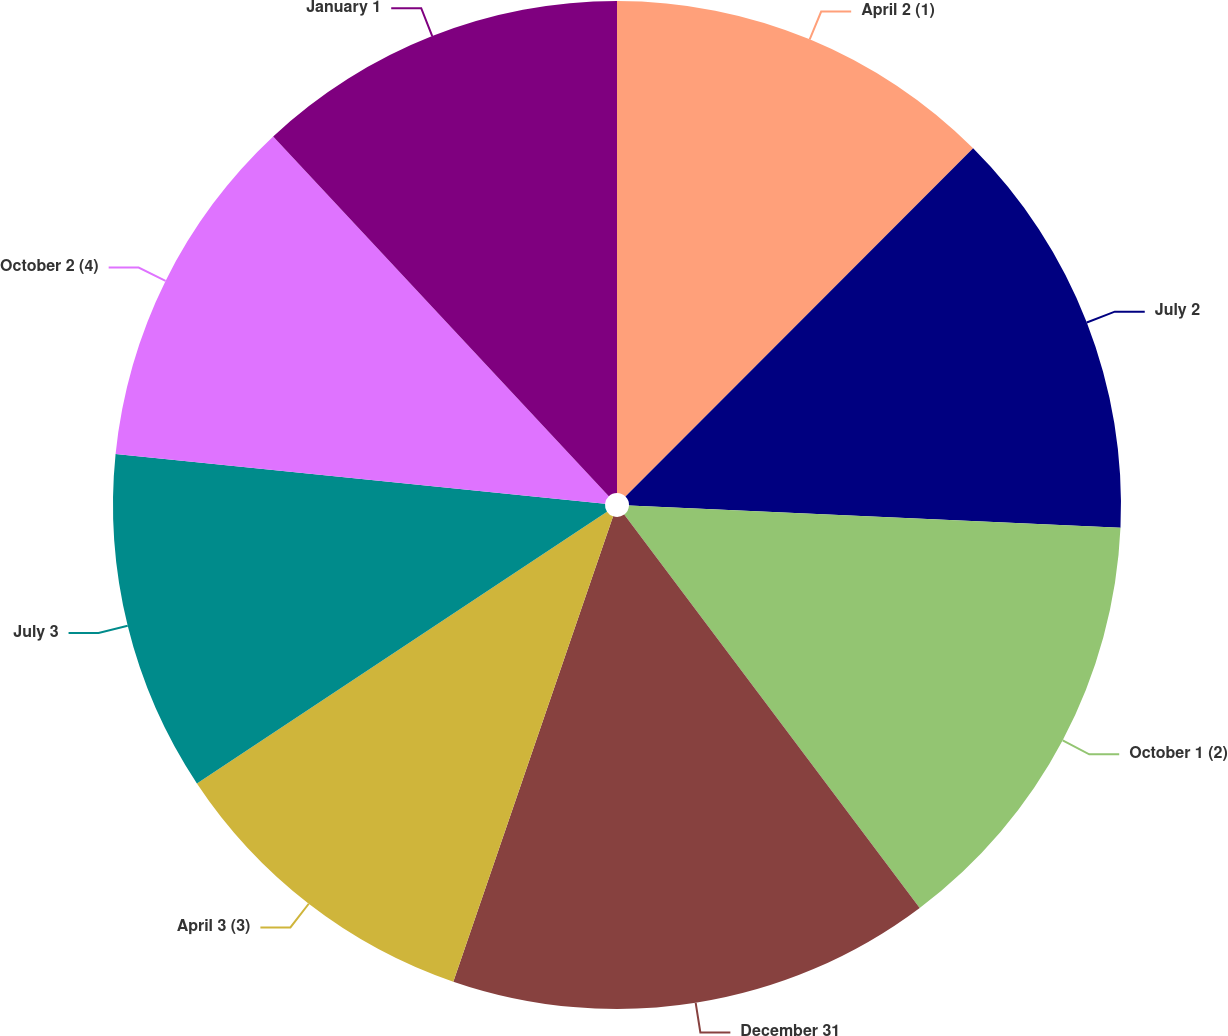Convert chart. <chart><loc_0><loc_0><loc_500><loc_500><pie_chart><fcel>April 2 (1)<fcel>July 2<fcel>October 1 (2)<fcel>December 31<fcel>April 3 (3)<fcel>July 3<fcel>October 2 (4)<fcel>January 1<nl><fcel>12.49%<fcel>13.23%<fcel>14.03%<fcel>15.52%<fcel>10.42%<fcel>10.93%<fcel>11.44%<fcel>11.95%<nl></chart> 